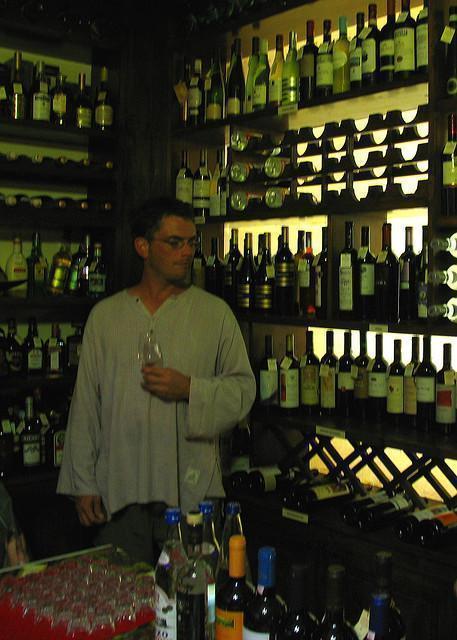Where is the man?
Select the accurate answer and provide explanation: 'Answer: answer
Rationale: rationale.'
Options: Garage, wine store, garden, stadium. Answer: wine store.
Rationale: The man is selling some wine since there are bottles behind him. 